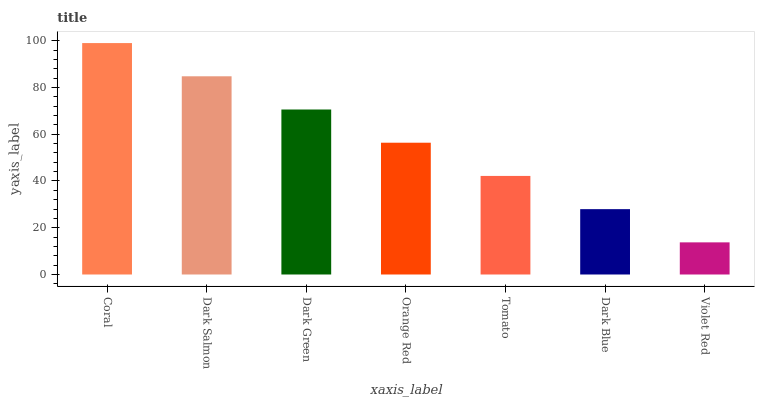Is Dark Salmon the minimum?
Answer yes or no. No. Is Dark Salmon the maximum?
Answer yes or no. No. Is Coral greater than Dark Salmon?
Answer yes or no. Yes. Is Dark Salmon less than Coral?
Answer yes or no. Yes. Is Dark Salmon greater than Coral?
Answer yes or no. No. Is Coral less than Dark Salmon?
Answer yes or no. No. Is Orange Red the high median?
Answer yes or no. Yes. Is Orange Red the low median?
Answer yes or no. Yes. Is Violet Red the high median?
Answer yes or no. No. Is Coral the low median?
Answer yes or no. No. 